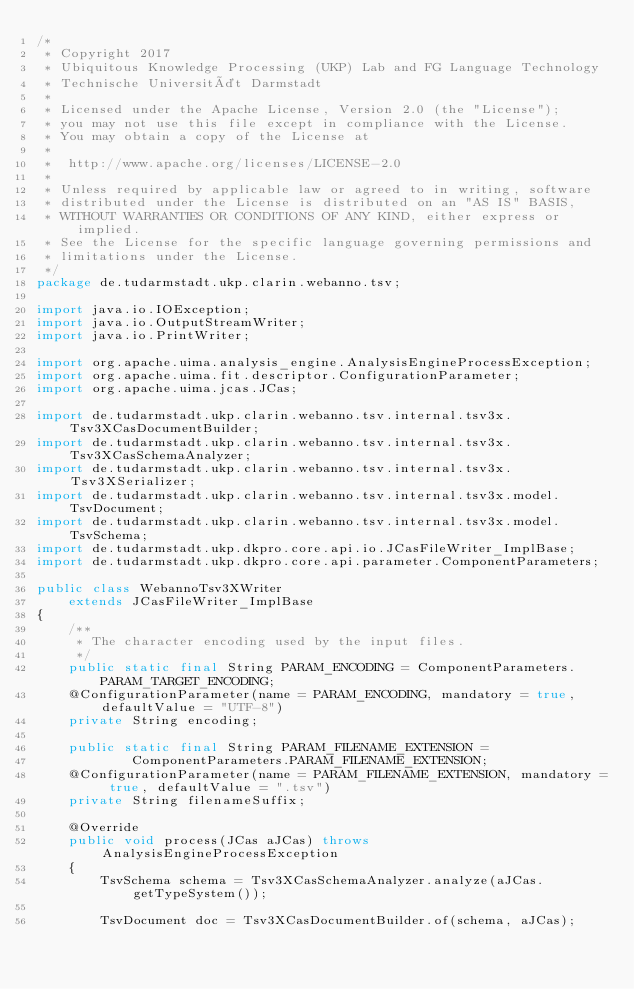Convert code to text. <code><loc_0><loc_0><loc_500><loc_500><_Java_>/*
 * Copyright 2017
 * Ubiquitous Knowledge Processing (UKP) Lab and FG Language Technology
 * Technische Universität Darmstadt
 *
 * Licensed under the Apache License, Version 2.0 (the "License");
 * you may not use this file except in compliance with the License.
 * You may obtain a copy of the License at
 *
 *  http://www.apache.org/licenses/LICENSE-2.0
 *
 * Unless required by applicable law or agreed to in writing, software
 * distributed under the License is distributed on an "AS IS" BASIS,
 * WITHOUT WARRANTIES OR CONDITIONS OF ANY KIND, either express or implied.
 * See the License for the specific language governing permissions and
 * limitations under the License.
 */
package de.tudarmstadt.ukp.clarin.webanno.tsv;

import java.io.IOException;
import java.io.OutputStreamWriter;
import java.io.PrintWriter;

import org.apache.uima.analysis_engine.AnalysisEngineProcessException;
import org.apache.uima.fit.descriptor.ConfigurationParameter;
import org.apache.uima.jcas.JCas;

import de.tudarmstadt.ukp.clarin.webanno.tsv.internal.tsv3x.Tsv3XCasDocumentBuilder;
import de.tudarmstadt.ukp.clarin.webanno.tsv.internal.tsv3x.Tsv3XCasSchemaAnalyzer;
import de.tudarmstadt.ukp.clarin.webanno.tsv.internal.tsv3x.Tsv3XSerializer;
import de.tudarmstadt.ukp.clarin.webanno.tsv.internal.tsv3x.model.TsvDocument;
import de.tudarmstadt.ukp.clarin.webanno.tsv.internal.tsv3x.model.TsvSchema;
import de.tudarmstadt.ukp.dkpro.core.api.io.JCasFileWriter_ImplBase;
import de.tudarmstadt.ukp.dkpro.core.api.parameter.ComponentParameters;

public class WebannoTsv3XWriter
    extends JCasFileWriter_ImplBase
{
    /**
     * The character encoding used by the input files.
     */
    public static final String PARAM_ENCODING = ComponentParameters.PARAM_TARGET_ENCODING;
    @ConfigurationParameter(name = PARAM_ENCODING, mandatory = true, defaultValue = "UTF-8")
    private String encoding;

    public static final String PARAM_FILENAME_EXTENSION = 
            ComponentParameters.PARAM_FILENAME_EXTENSION;
    @ConfigurationParameter(name = PARAM_FILENAME_EXTENSION, mandatory = true, defaultValue = ".tsv")
    private String filenameSuffix;

    @Override
    public void process(JCas aJCas) throws AnalysisEngineProcessException
    {
        TsvSchema schema = Tsv3XCasSchemaAnalyzer.analyze(aJCas.getTypeSystem());
        
        TsvDocument doc = Tsv3XCasDocumentBuilder.of(schema, aJCas);
        </code> 